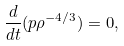Convert formula to latex. <formula><loc_0><loc_0><loc_500><loc_500>\frac { d } { d t } ( p \rho ^ { - 4 / 3 } ) = 0 ,</formula> 